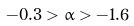<formula> <loc_0><loc_0><loc_500><loc_500>- 0 . 3 > \alpha > - 1 . 6</formula> 